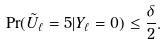<formula> <loc_0><loc_0><loc_500><loc_500>\Pr ( \tilde { U } _ { \ell } = 5 | Y _ { \ell } = 0 ) \leq \frac { \delta } { 2 } .</formula> 